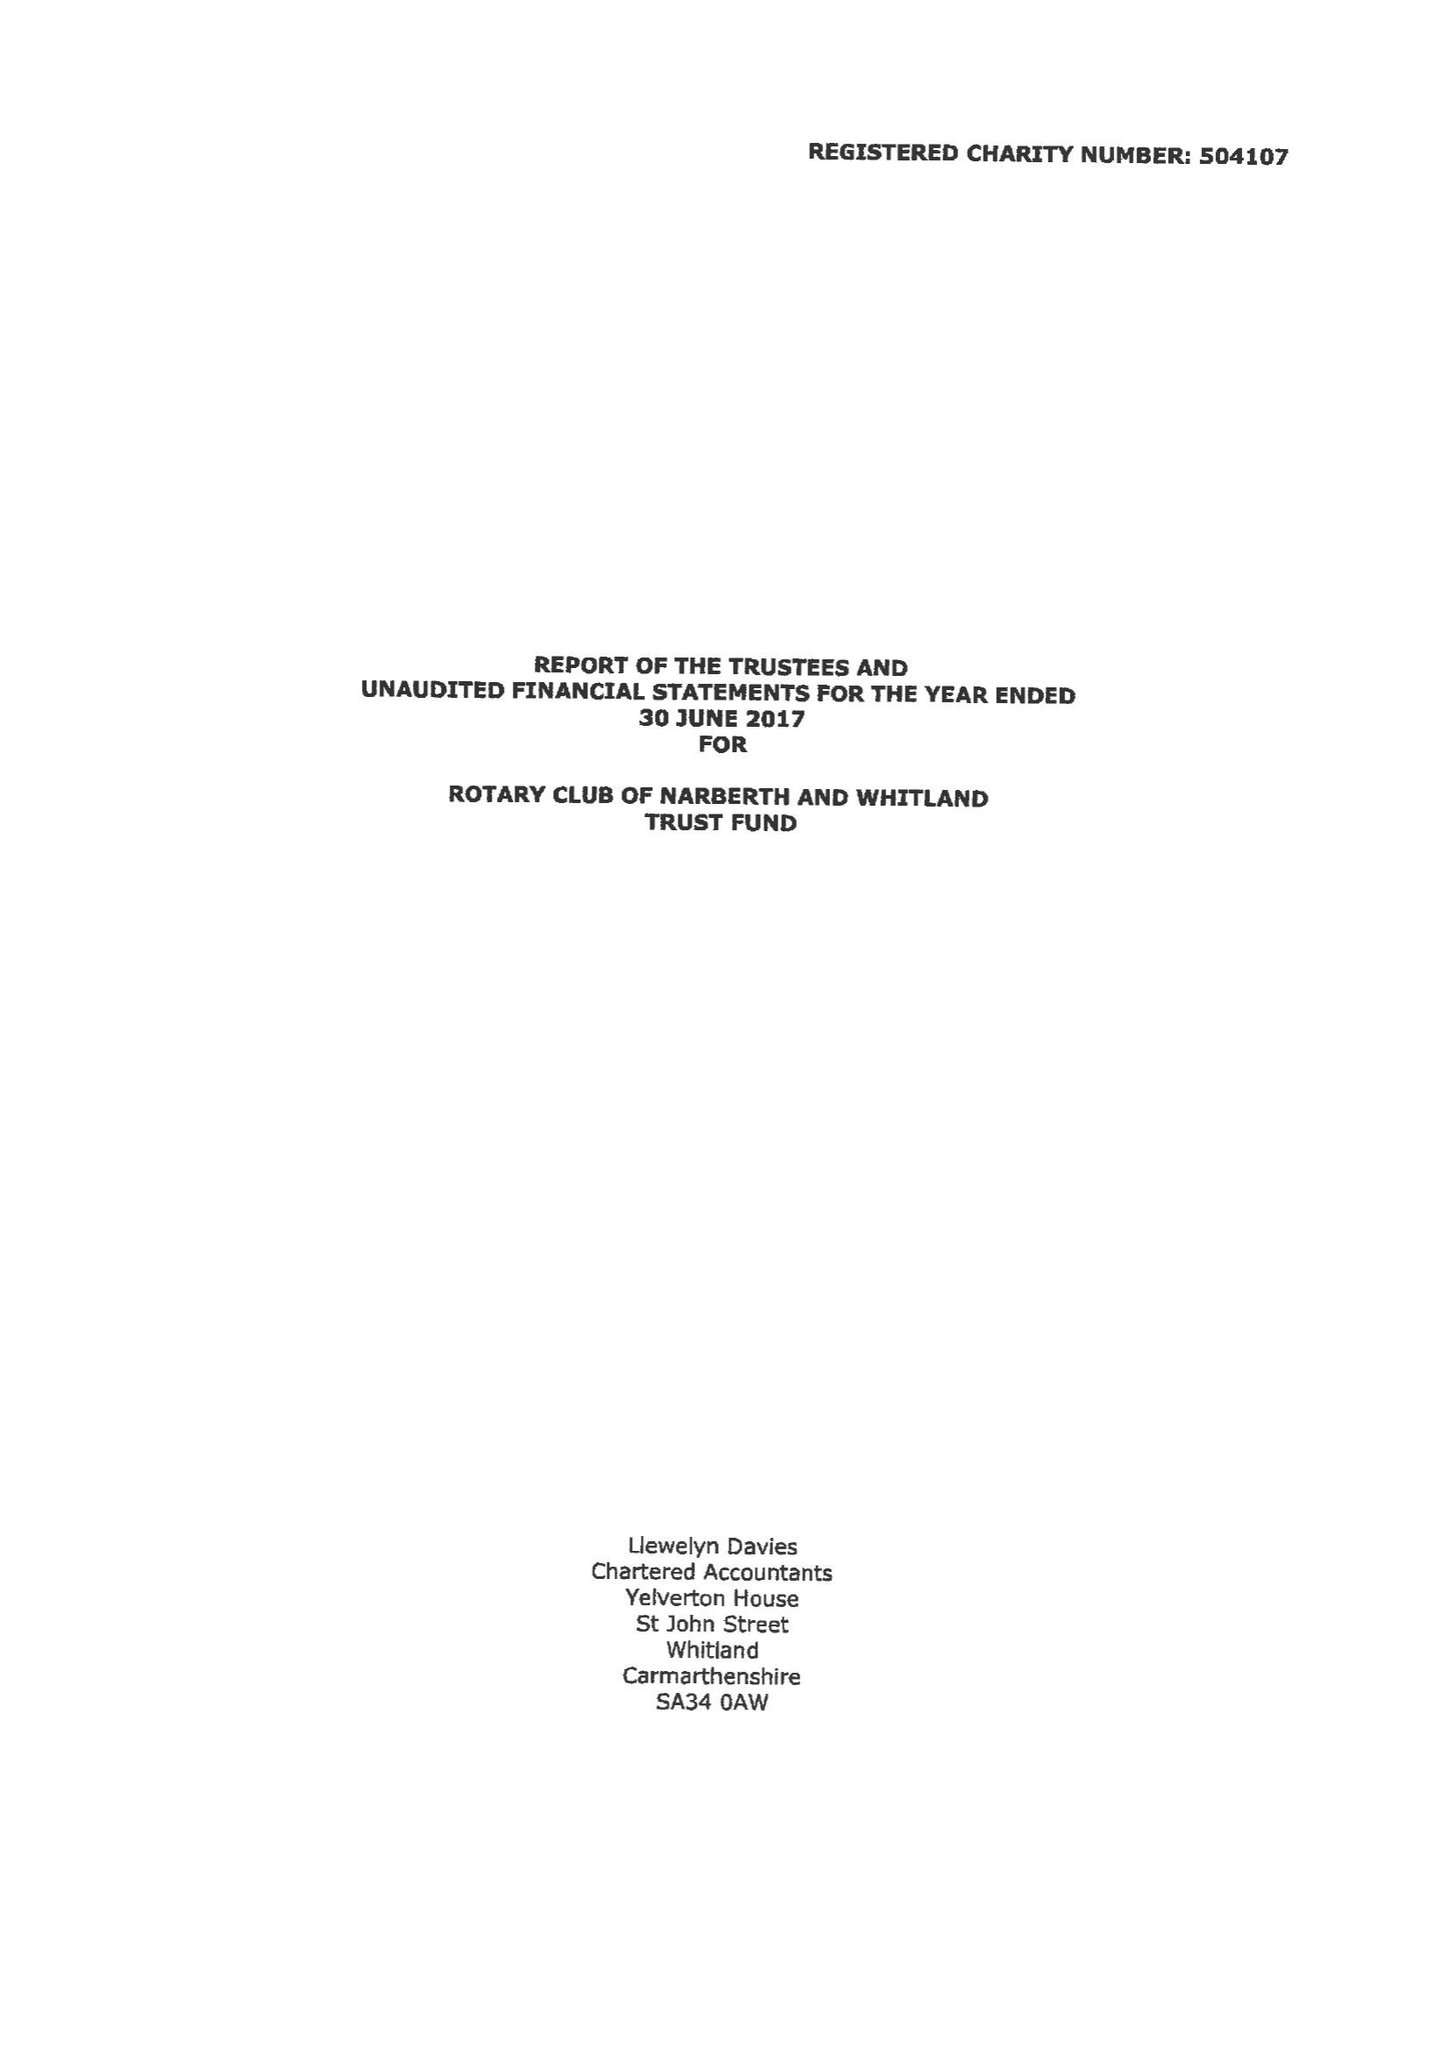What is the value for the address__street_line?
Answer the question using a single word or phrase. None 